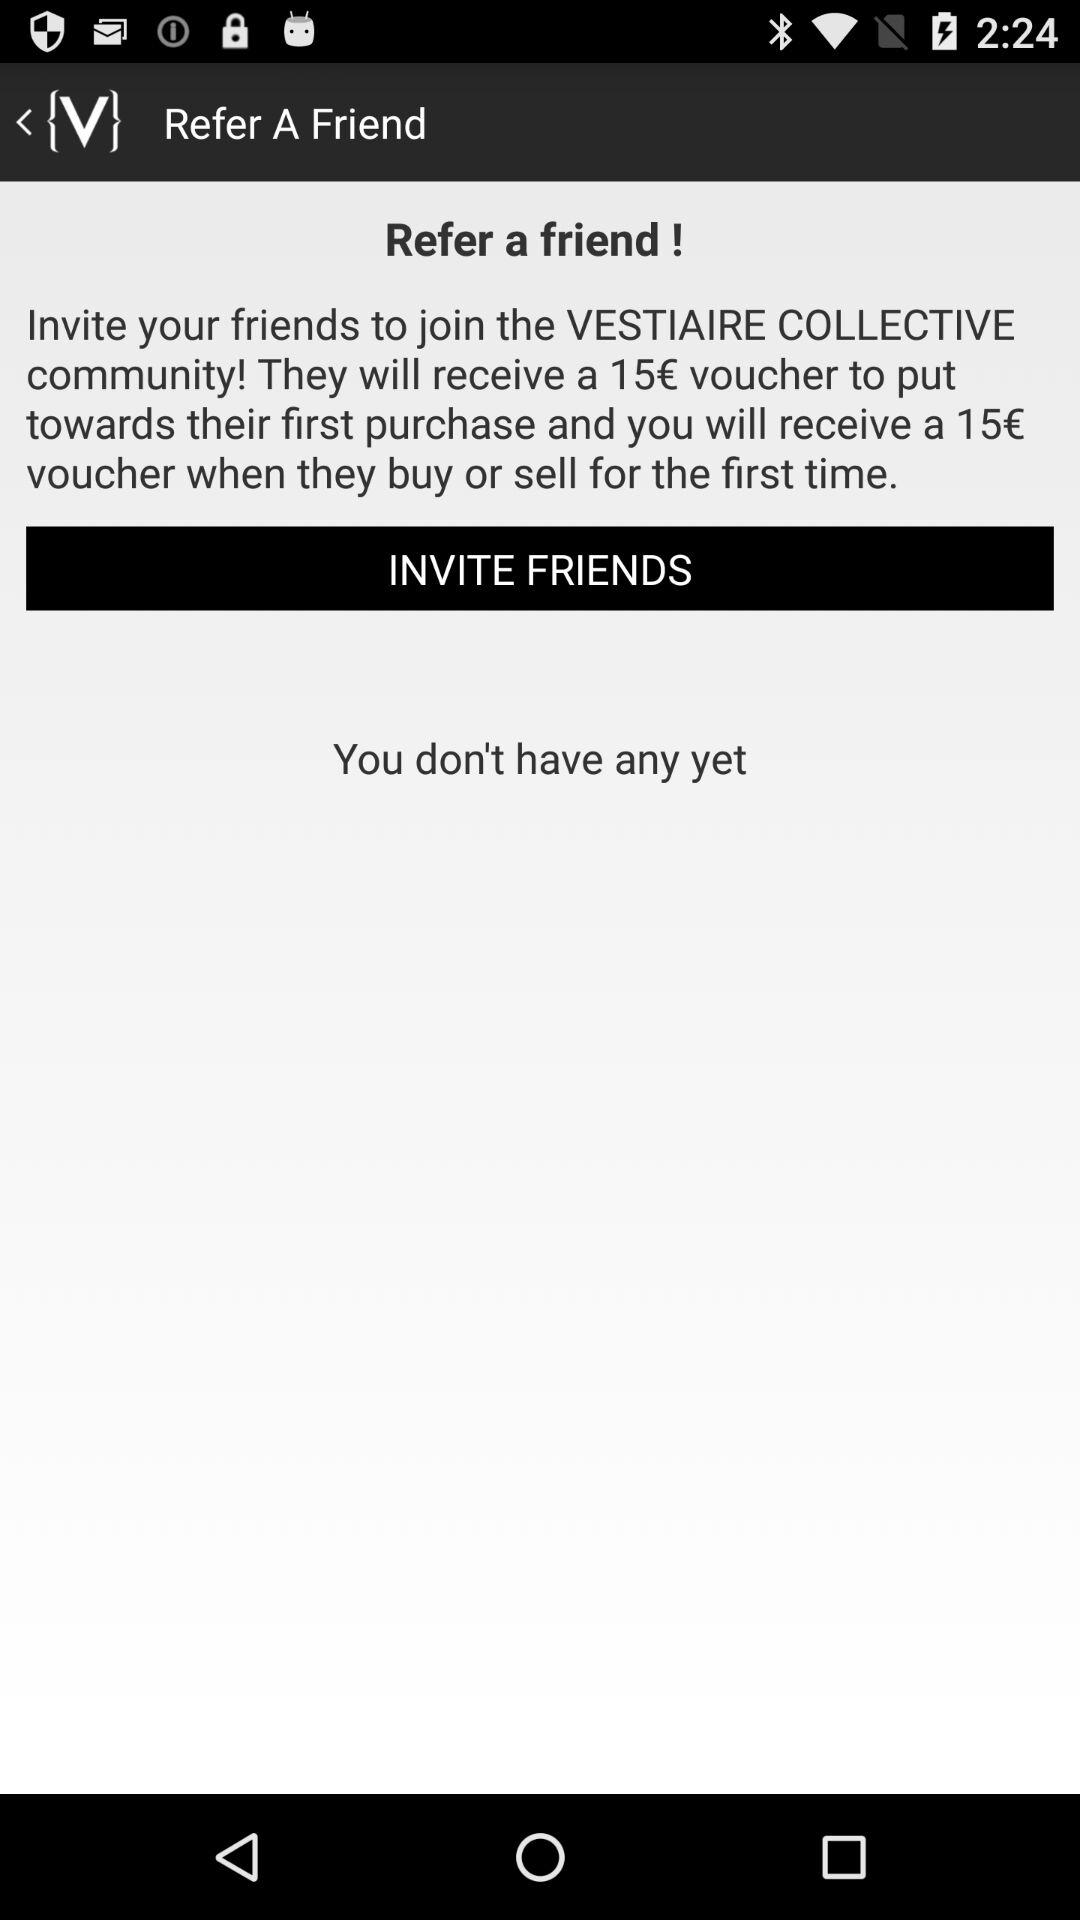How many vouchers do you receive when your friend buys or sells for the first time?
Answer the question using a single word or phrase. 15 